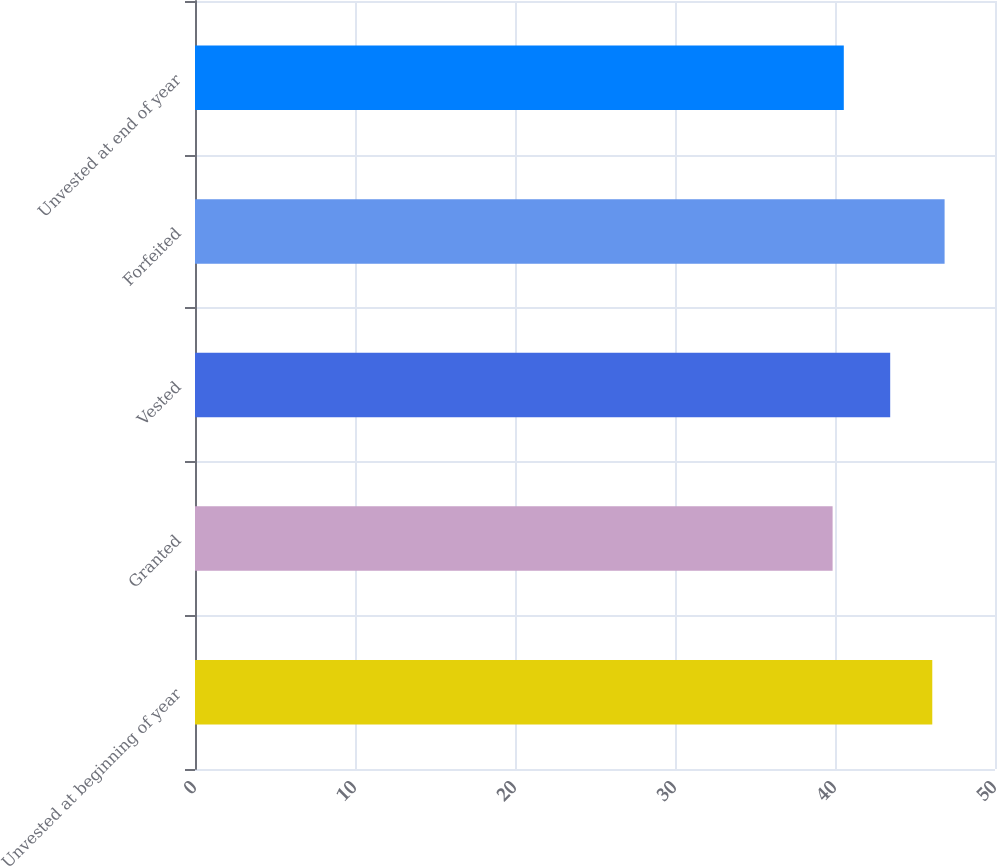Convert chart to OTSL. <chart><loc_0><loc_0><loc_500><loc_500><bar_chart><fcel>Unvested at beginning of year<fcel>Granted<fcel>Vested<fcel>Forfeited<fcel>Unvested at end of year<nl><fcel>46.08<fcel>39.85<fcel>43.45<fcel>46.85<fcel>40.55<nl></chart> 